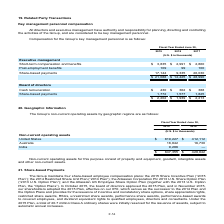According to Atlassian Plc's financial document, What does non-current operating assets consists of? Property and equipment, goodwill, intangible assets and other non-current assets. The document states: "rent operating assets for this purpose consist of property and equipment, goodwill, intangible assets and other non-current assets...." Also, What is the total non-current operating assets for fiscal year ended June 30, 2018 and 2019 respectively? The document shows two values: $428,842 and $847,355 (in thousands). From the document: "$ 847,355 $ 428,842 $ 847,355 $ 428,842..." Also, What is the value of non-current operating assets in India in fiscal year ended June 30, 2019? According to the financial document, 9,286 (in thousands). The relevant text states: "India 9,286 —..." Also, can you calculate: What is the average total non-current operating assets for fiscal years ended June 30, 2018 and 2019? To answer this question, I need to perform calculations using the financial data. The calculation is: (847,355+428,842)/2, which equals 638098.5 (in thousands). This is based on the information: "$ 847,355 $ 428,842 $ 847,355 $ 428,842..." The key data points involved are: 428,842, 847,355. Also, In fiscal year ended June 30, 2019, how many geographic regions have non-current operating assets of more than $10,000 thousand? Counting the relevant items in the document: United States ,  Australia, I find 2 instances. The key data points involved are: Australia, United States. Also, can you calculate: In fiscal year ended June 30, 2018, what is the percentage constitution of the non-current operating assets in the United States among the total non-current operating assets owned by the Group? Based on the calculation: 412,112/428,842, the result is 96.1 (percentage). This is based on the information: "urrent operating assets United States $ 819,227 $ 412,112 $ 847,355 $ 428,842..." The key data points involved are: 412,112, 428,842. 